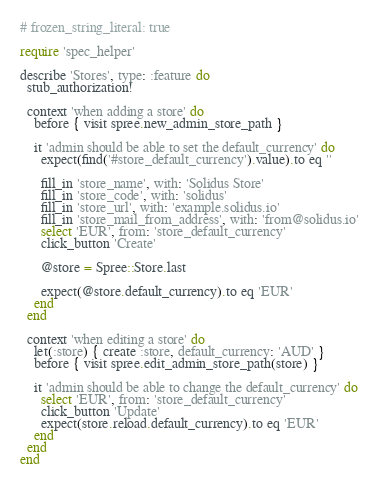<code> <loc_0><loc_0><loc_500><loc_500><_Ruby_># frozen_string_literal: true

require 'spec_helper'

describe 'Stores', type: :feature do
  stub_authorization!

  context 'when adding a store' do
    before { visit spree.new_admin_store_path }

    it 'admin should be able to set the default_currency' do
      expect(find('#store_default_currency').value).to eq ''

      fill_in 'store_name', with: 'Solidus Store'
      fill_in 'store_code', with: 'solidus'
      fill_in 'store_url', with: 'example.solidus.io'
      fill_in 'store_mail_from_address', with: 'from@solidus.io'
      select 'EUR', from: 'store_default_currency'
      click_button 'Create'

      @store = Spree::Store.last

      expect(@store.default_currency).to eq 'EUR'
    end
  end

  context 'when editing a store' do
    let(:store) { create :store, default_currency: 'AUD' }
    before { visit spree.edit_admin_store_path(store) }

    it 'admin should be able to change the default_currency' do
      select 'EUR', from: 'store_default_currency'
      click_button 'Update'
      expect(store.reload.default_currency).to eq 'EUR'
    end
  end
end
</code> 